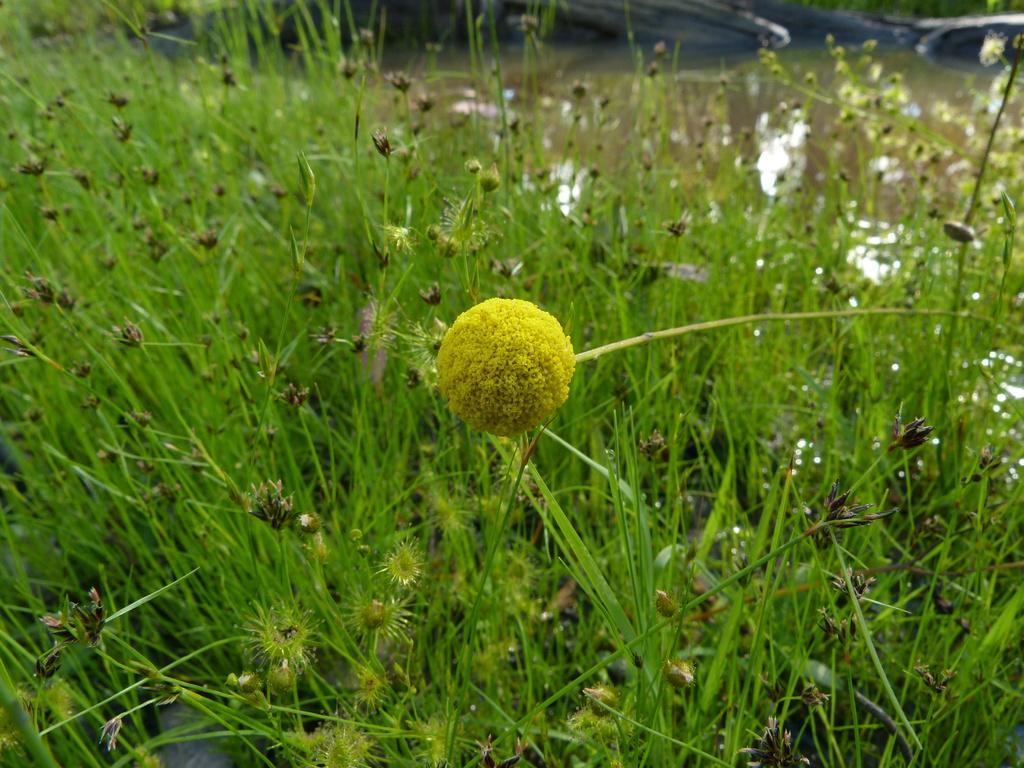In one or two sentences, can you explain what this image depicts? In this picture there is a yellow color flower in the center of the image and there are plants around the area of the image. 